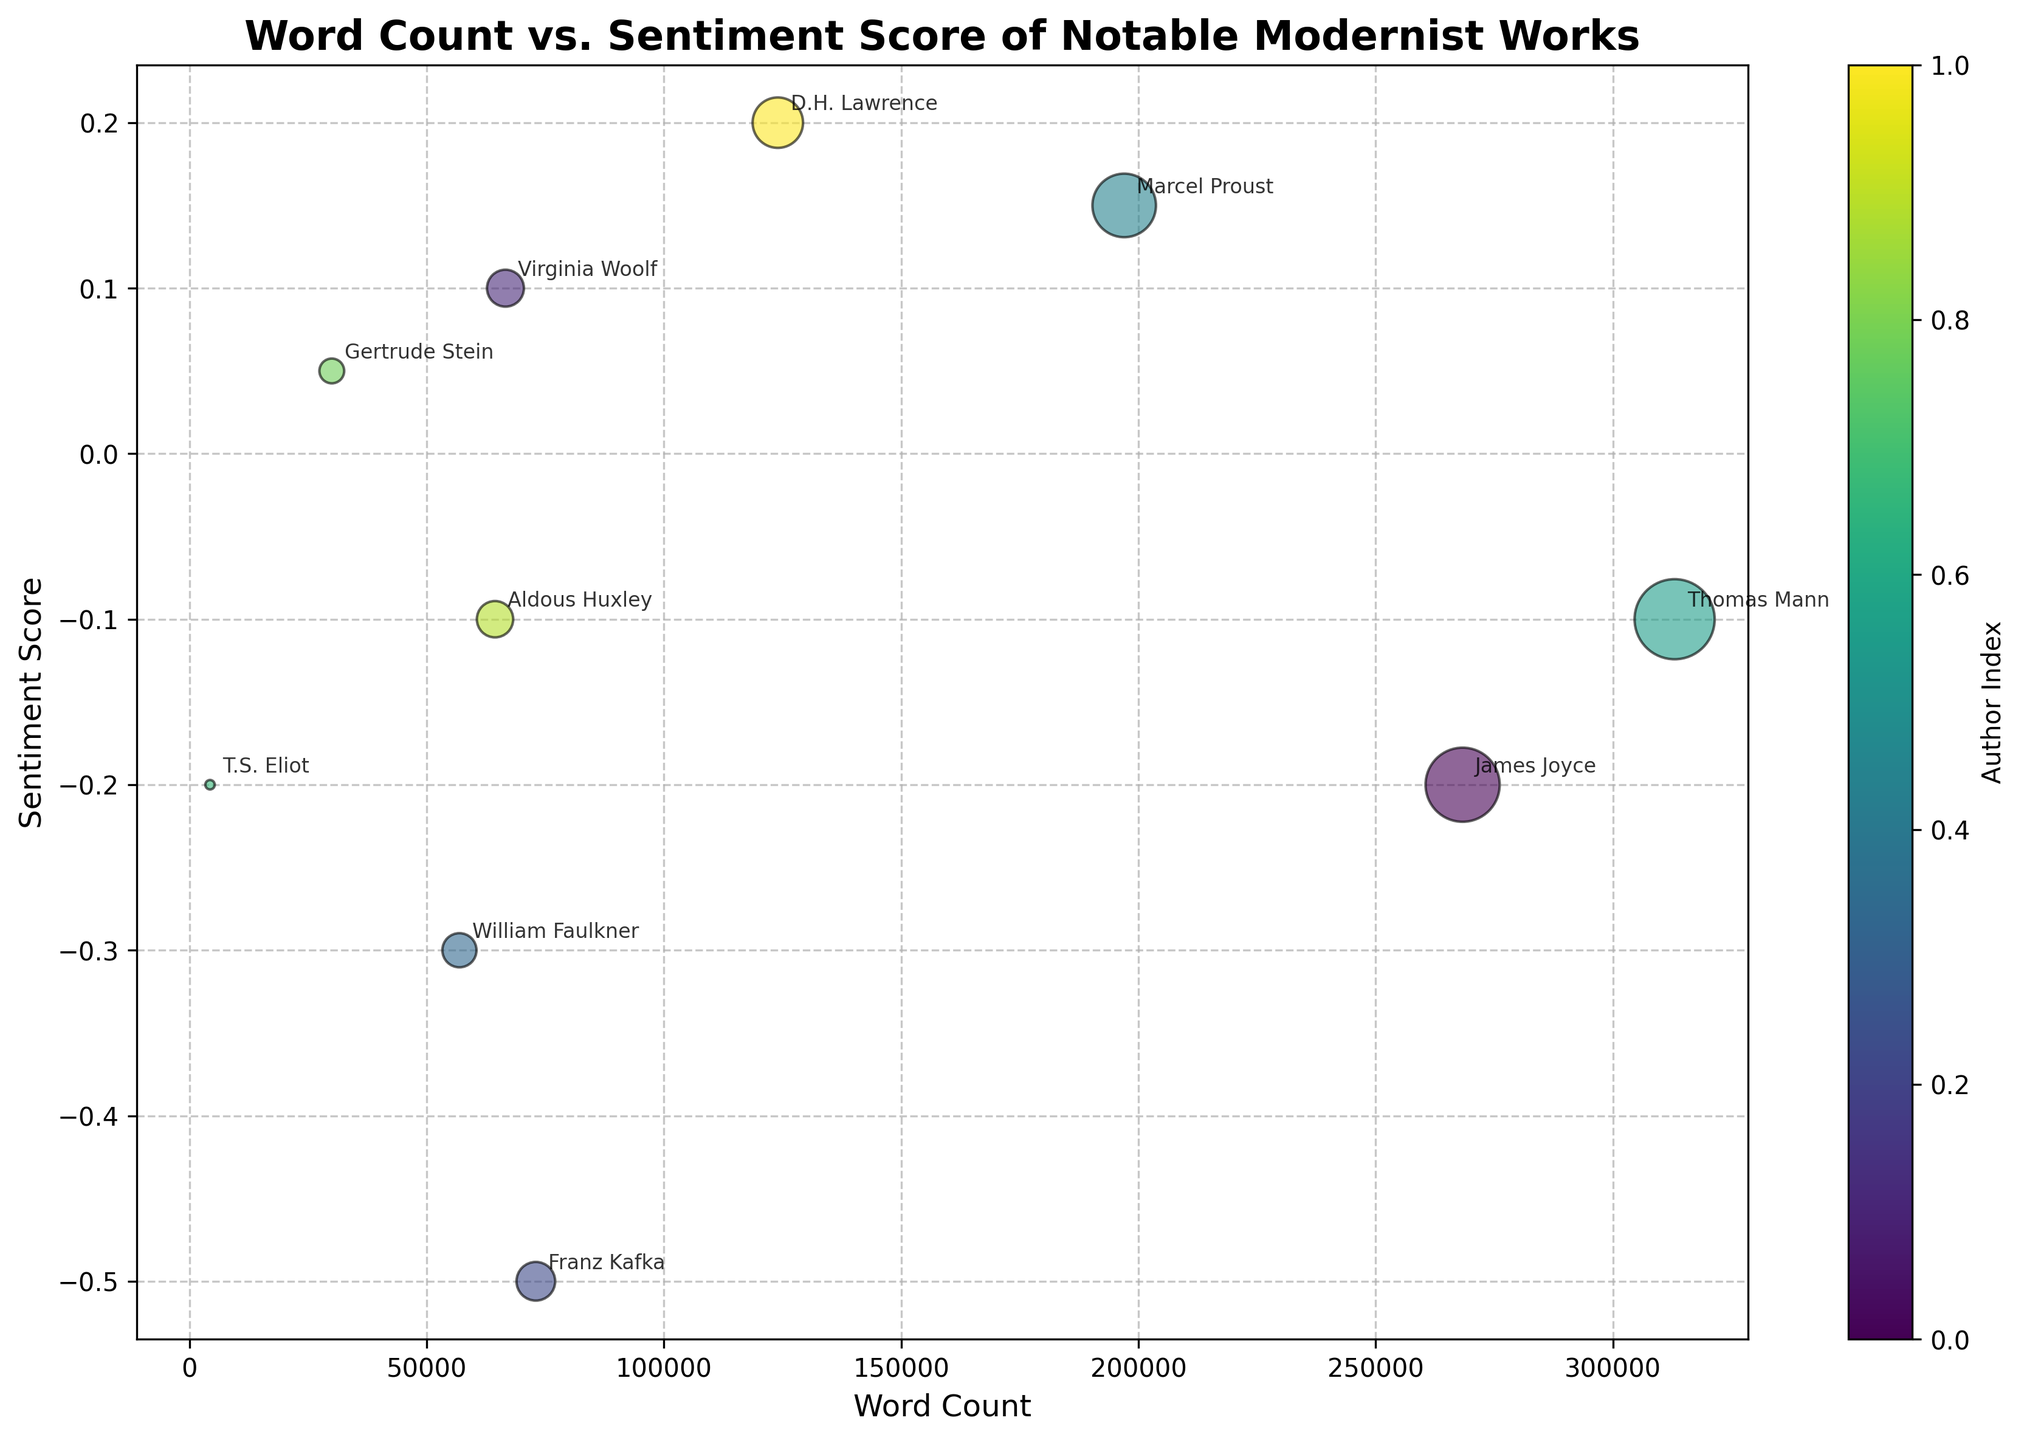What is the title of the figure? The title of the figure is displayed at the top of the chart. It reads "Word Count vs. Sentiment Score of Notable Modernist Works".
Answer: Word Count vs. Sentiment Score of Notable Modernist Works Which work has the highest word count? By observing the x-axis, the bubble farthest to the right represents the work with the highest word count. This bubble is for "The Magic Mountain" by Thomas Mann.
Answer: The Magic Mountain How many works have a positive sentiment score? Positive sentiment scores are shown on the upper half of the y-axis. By counting the bubbles above the x-axis, we find four works with positive sentiment scores: "To the Lighthouse," "Swann's Way," "Tender Buttons," and "Lady Chatterley's Lover."
Answer: 4 Which author has the work with the smallest word count? The smallest word count is represented by the bubble that is farthest to the left on the x-axis. This bubble corresponds to "The Waste Land" by T.S. Eliot.
Answer: T.S. Eliot What is the sentiment score of "Lady Chatterley's Lover"? By finding "Lady Chatterley's Lover" in the figure and checking its position on the y-axis, we see that its sentiment score is 0.2.
Answer: 0.2 Compare the word counts of "Ulysses" and "Swann's Way." Which one is higher? First, locate the bubbles for both works. "Ulysses" by James Joyce is on the right with a word count of 268,320, while "Swann's Way" by Marcel Proust is on the left with a word count of 197,000. Therefore, "Ulysses" has a higher word count.
Answer: Ulysses What is the average sentiment score of all the works shown in the chart? Summing up the sentiment scores: -0.2 + 0.1 - 0.5 - 0.3 + 0.15 - 0.1 - 0.2 + 0.05 - 0.1 + 0.2 = -0.8. The total number of works is 10, so the average sentiment score is -0.8/10 = -0.08.
Answer: -0.08 Which work has a better sentiment score, "The Trial" or "Brave New World"? Checking the sentiment scores of these works, "The Trial" by Franz Kafka has a sentiment score of -0.5, while "Brave New World" by Aldous Huxley has a sentiment score of -0.1. Hence, "Brave New World" has a better sentiment score.
Answer: Brave New World Identify the work with the most neutral (closest to zero) sentiment score. The work with a sentiment score nearest to zero can be found at the position closest to the x-axis but not exactly zero. This is "Tender Buttons" by Gertrude Stein with a sentiment score of 0.05.
Answer: Tender Buttons 